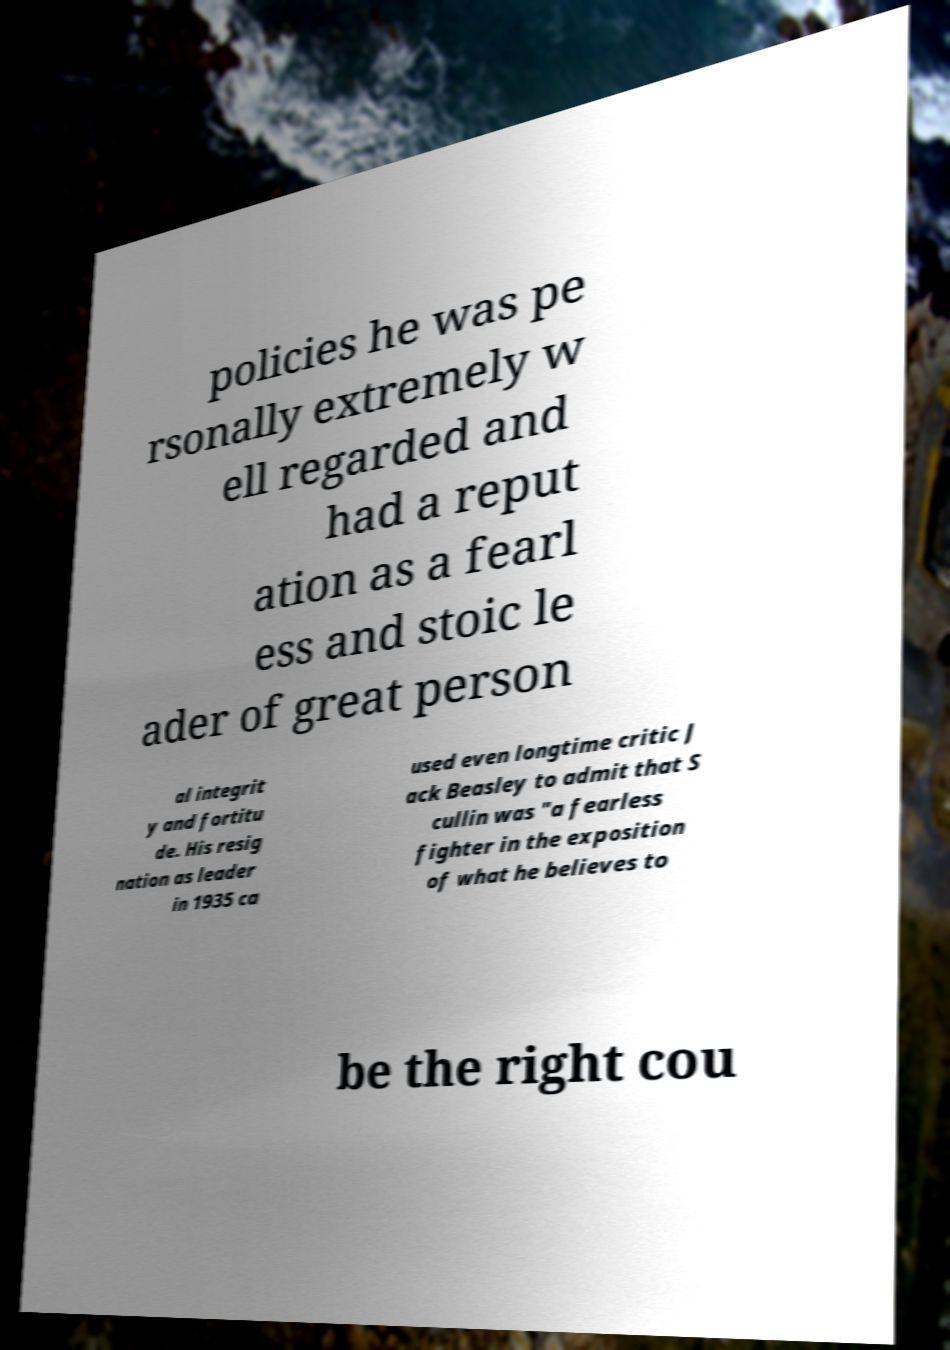There's text embedded in this image that I need extracted. Can you transcribe it verbatim? policies he was pe rsonally extremely w ell regarded and had a reput ation as a fearl ess and stoic le ader of great person al integrit y and fortitu de. His resig nation as leader in 1935 ca used even longtime critic J ack Beasley to admit that S cullin was "a fearless fighter in the exposition of what he believes to be the right cou 